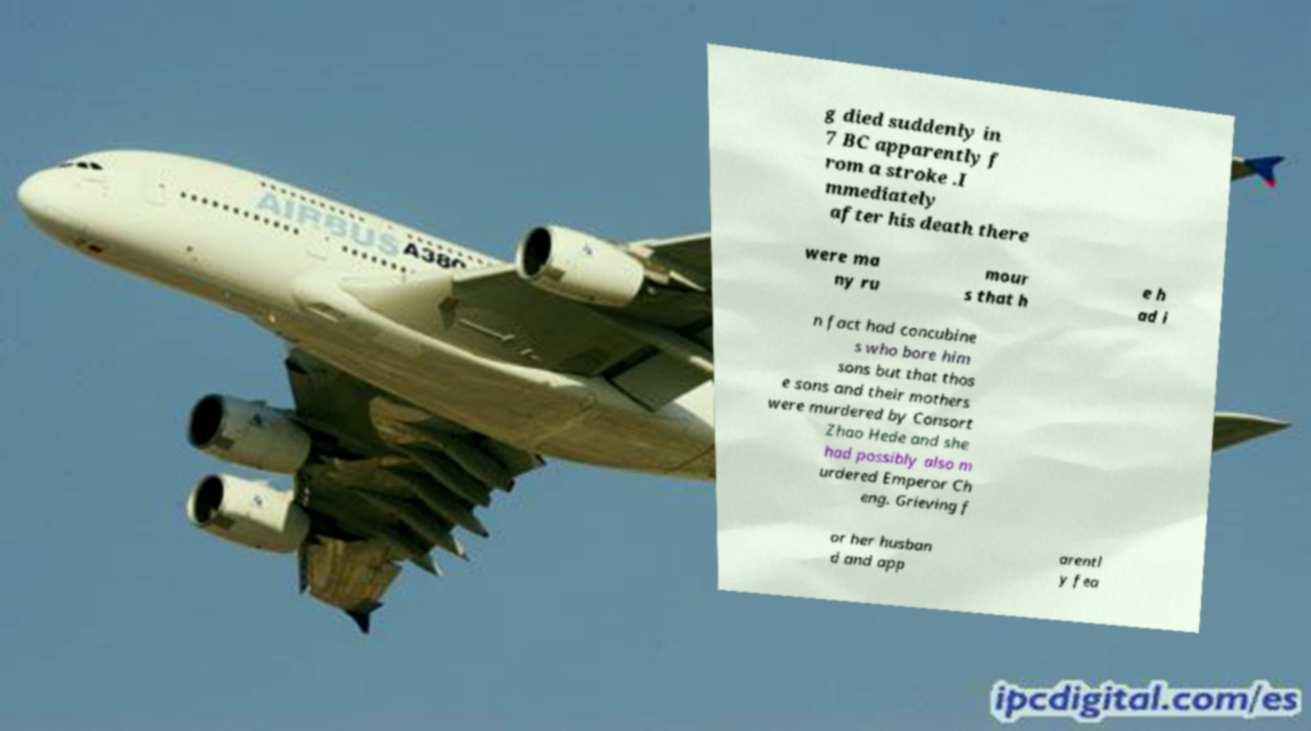Could you extract and type out the text from this image? g died suddenly in 7 BC apparently f rom a stroke .I mmediately after his death there were ma ny ru mour s that h e h ad i n fact had concubine s who bore him sons but that thos e sons and their mothers were murdered by Consort Zhao Hede and she had possibly also m urdered Emperor Ch eng. Grieving f or her husban d and app arentl y fea 